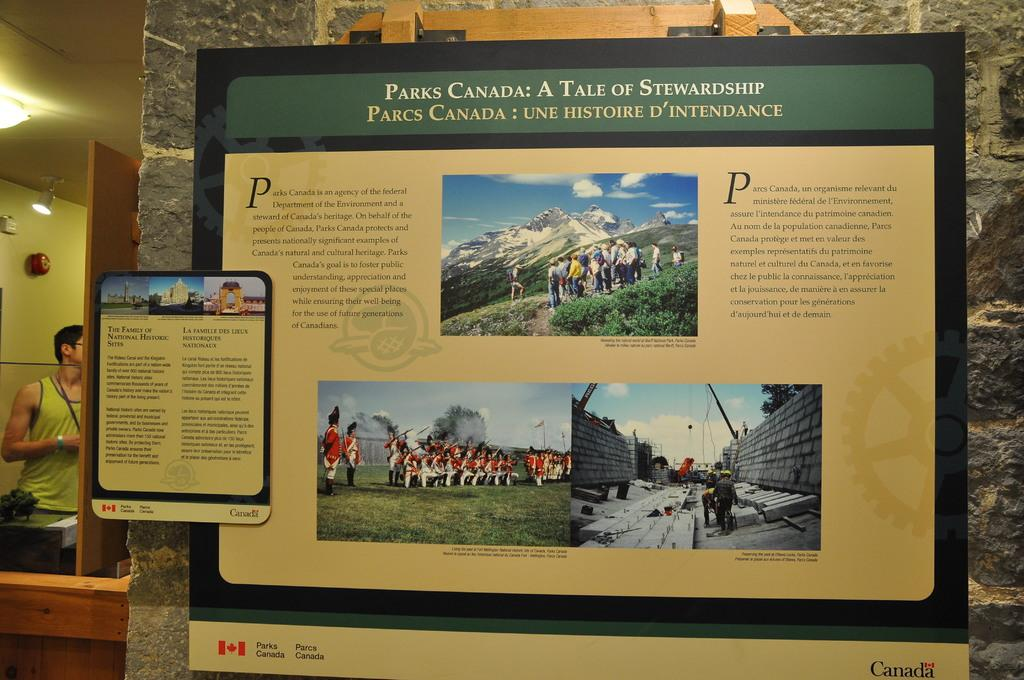<image>
Write a terse but informative summary of the picture. A sign describes a tale of stewardship for parks canada. 